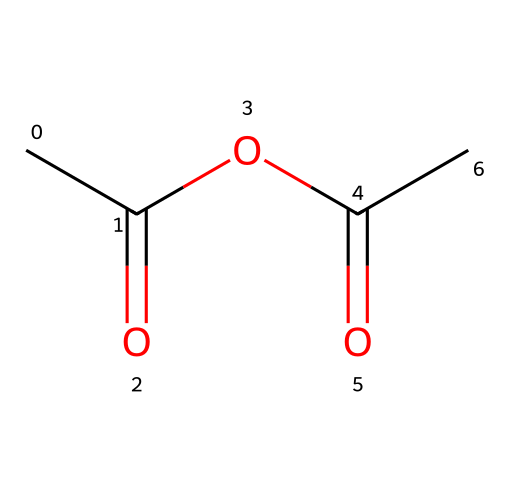What is the molecular formula of acetic anhydride? By interpreting the SMILES representation, we can count the atoms: there are four carbon atoms (C), six hydrogen atoms (H), and three oxygen atoms (O) present in the structure. Thus, the molecular formula is derived as C4H6O3.
Answer: C4H6O3 How many carbon atoms are in acetic anhydride? In the provided SMILES string, we can identify the presence of four carbon atoms by counting each occurrence of 'C'.
Answer: 4 What type of chemical is acetic anhydride? Acetic anhydride is classified as an acid anhydride since it is derived from acetic acid and contains the anhydride functional group (-C(=O)OC(=O)-).
Answer: acid anhydride What functional groups are present in acetic anhydride? The functional groups can be identified by examining the structure: the molecule contains two carbonyl groups (C=O) and one ether bond (C-O-C), which are characteristic of acetic anhydride.
Answer: carbonyl, ether How many hydrogen atoms are connected to the carbonyl groups in acetic anhydride? In acetic anhydride, there are six hydrogen atoms connected overall, but none are connected directly to the carbonyl carbons since they are bonded to oxygens. Therefore, the carbonyl groups do not have hydrogen atoms connected directly to them.
Answer: 0 What is the significance of acetic anhydride in traditional Indian fabric dyes? Acetic anhydride is often used as a reagent in dyeing processes to enhance color uptake and fixation on fabrics due to its properties as an acylation agent, improving the interaction between dyes and fibers.
Answer: dye fixation 